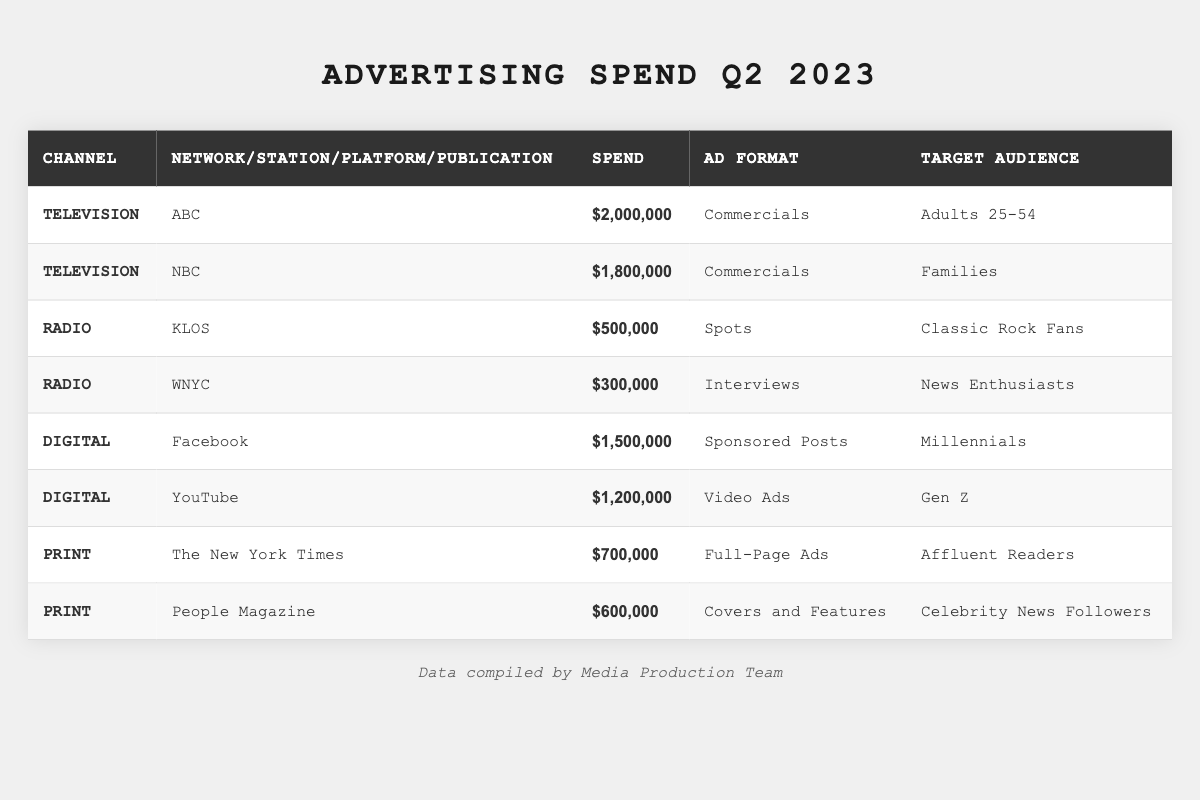What is the total advertising spend for Television in Q2 2023? The table lists two entries under Television: ABC with a spend of $2,000,000 and NBC with a spend of $1,800,000. Adding these amounts gives us $2,000,000 + $1,800,000 = $3,800,000.
Answer: $3,800,000 Which media channel had the highest advertising spend in Q2 2023? From the table, the highest spend is $2,000,000 for ABC under Television. This value is greater than all other entries listed in the table.
Answer: ABC How much was spent on Radio advertising combined? The table shows KLOS with a spend of $500,000 and WNYC with a spend of $300,000. Adding these amounts: $500,000 + $300,000 = $800,000.
Answer: $800,000 Did Facebook have a higher advertising spend than YouTube in Q2 2023? The table shows Facebook had a spend of $1,500,000 and YouTube had a spend of $1,200,000. Since $1,500,000 is greater than $1,200,000, the statement is true.
Answer: Yes What percentage of the total advertising spend in Q2 2023 was allocated to Print media? First, we need to find the total advertising spend across all channels, which is $2,000,000 (ABC) + $1,800,000 (NBC) + $500,000 (KLOS) + $300,000 (WNYC) + $1,500,000 (Facebook) + $1,200,000 (YouTube) + $700,000 (The New York Times) + $600,000 (People Magazine) = $8,100,000. The total spend on Print is $700,000 + $600,000 = $1,300,000. The percentage is calculated as ($1,300,000 / $8,100,000) * 100 = 16.05%.
Answer: 16.05% Which channel had the biggest audience target demographic in terms of number of different demographic groups? The table lists Television with two entries targeting different demographics (Adults 25-54 and Families) and Digital with two entries targeting different demographics (Millennials and Gen Z). Radio has two as well (Classic Rock Fans and News Enthusiasts), and Print has two (Affluent Readers and Celebrity News Followers). Since all channels have two different target demographics, they tie.
Answer: Tie What is the difference in spend between the highest and lowest spending media channels? The highest spend is $2,000,000 (ABC) and the lowest is $300,000 (WNYC). The difference is $2,000,000 - $300,000 = $1,700,000.
Answer: $1,700,000 Which media channel had the least amount spent on advertising, and how much was it? The table shows that WNYC, with a spend of $300,000, is the least among all channels listed.
Answer: WNYC, $300,000 